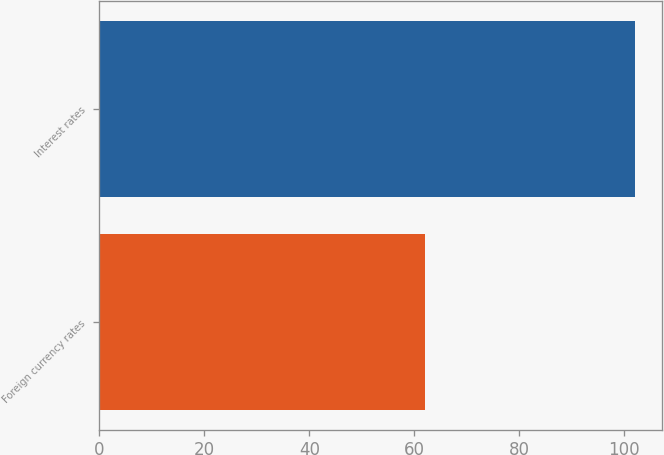Convert chart. <chart><loc_0><loc_0><loc_500><loc_500><bar_chart><fcel>Foreign currency rates<fcel>Interest rates<nl><fcel>62<fcel>102<nl></chart> 